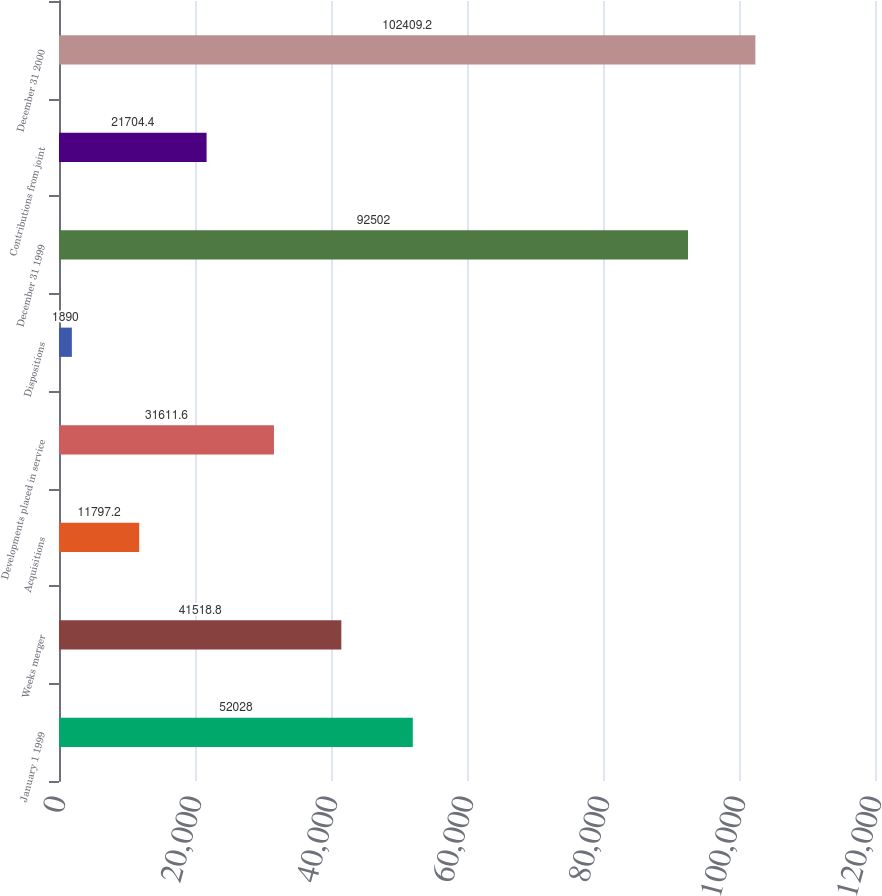Convert chart to OTSL. <chart><loc_0><loc_0><loc_500><loc_500><bar_chart><fcel>January 1 1999<fcel>Weeks merger<fcel>Acquisitions<fcel>Developments placed in service<fcel>Dispositions<fcel>December 31 1999<fcel>Contributions from joint<fcel>December 31 2000<nl><fcel>52028<fcel>41518.8<fcel>11797.2<fcel>31611.6<fcel>1890<fcel>92502<fcel>21704.4<fcel>102409<nl></chart> 